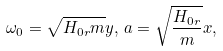Convert formula to latex. <formula><loc_0><loc_0><loc_500><loc_500>\omega _ { 0 } = \sqrt { H _ { 0 r } m } y , \, a = \sqrt { \frac { H _ { 0 r } } { m } } x ,</formula> 